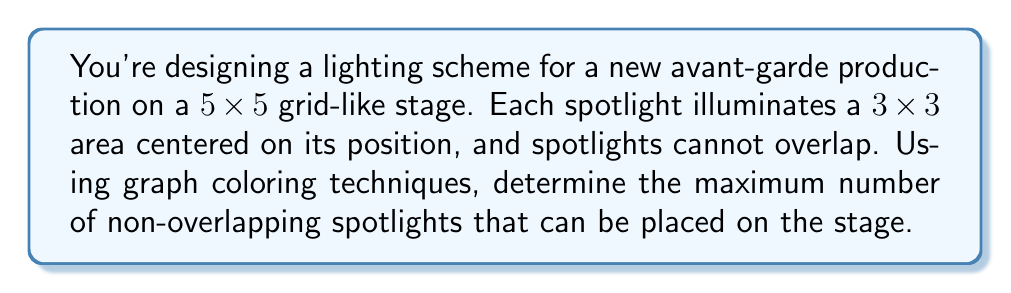Show me your answer to this math problem. To solve this problem, we'll use graph coloring techniques:

1) First, we need to create a graph representation of the stage:
   - Each potential spotlight position is a vertex.
   - Two vertices are connected by an edge if their spotlights would overlap.

2) In a 5x5 grid, we have 25 potential spotlight positions. However, due to the 3x3 illumination area, we can't place spotlights on the edge of the stage. This leaves us with a 3x3 grid of possible spotlight positions.

3) Let's number these positions from 1 to 9:

   [asy]
   unitsize(1cm);
   for(int i=0; i<3; ++i)
     for(int j=0; j<3; ++j)
       dot((i,j));
   label("1", (0,2));
   label("2", (1,2));
   label("3", (2,2));
   label("4", (0,1));
   label("5", (1,1));
   label("6", (2,1));
   label("7", (0,0));
   label("8", (1,0));
   label("9", (2,0));
   [/asy]

4) Now, we need to connect vertices where spotlights would overlap. Each spotlight overlaps with its immediate neighbors (up, down, left, right) and diagonal neighbors.

5) This results in a graph where each vertex is connected to all other vertices except the one directly opposite in the 3x3 grid. For example, vertex 1 is connected to all vertices except 9, vertex 2 is connected to all except 8, etc.

6) This graph is known as a complement of a perfect matching on 9 vertices.

7) The chromatic number of this graph (minimum number of colors needed to color the graph such that no adjacent vertices have the same color) is 3.

8) In terms of our spotlights, each color in the graph coloring represents a set of non-overlapping spotlights.

9) Therefore, the maximum number of non-overlapping spotlights is equal to the size of the largest color class in an optimal coloring.

10) In an optimal 3-coloring of this graph, the color classes will have sizes 3, 3, and 3.

Thus, the maximum number of non-overlapping spotlights is 3.
Answer: 3 spotlights 